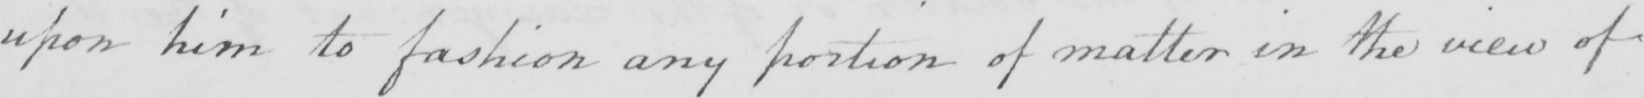Please provide the text content of this handwritten line. upon him to fashion any portion of matter in the view of 